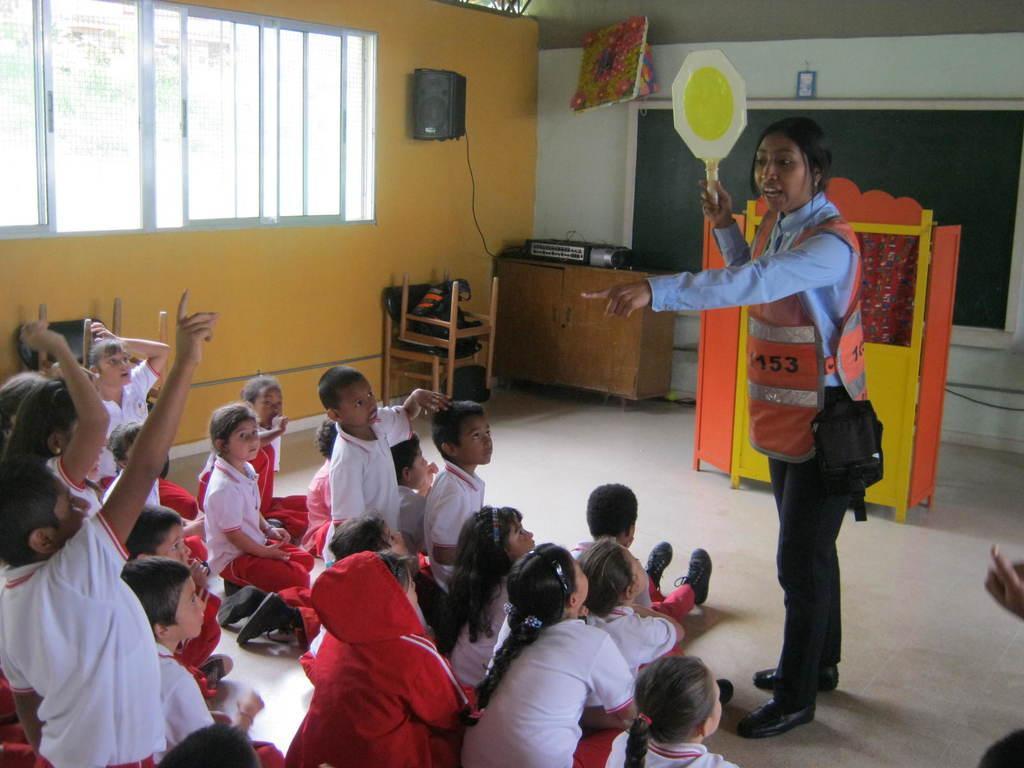Could you give a brief overview of what you see in this image? In this image, we can see kids wearing uniforms and there is a standing and wearing a safety jacket and holding a board. In the background, there are stands and we can see a board and some objects on the wall and there are windows. At the bottom, there is a floor. 